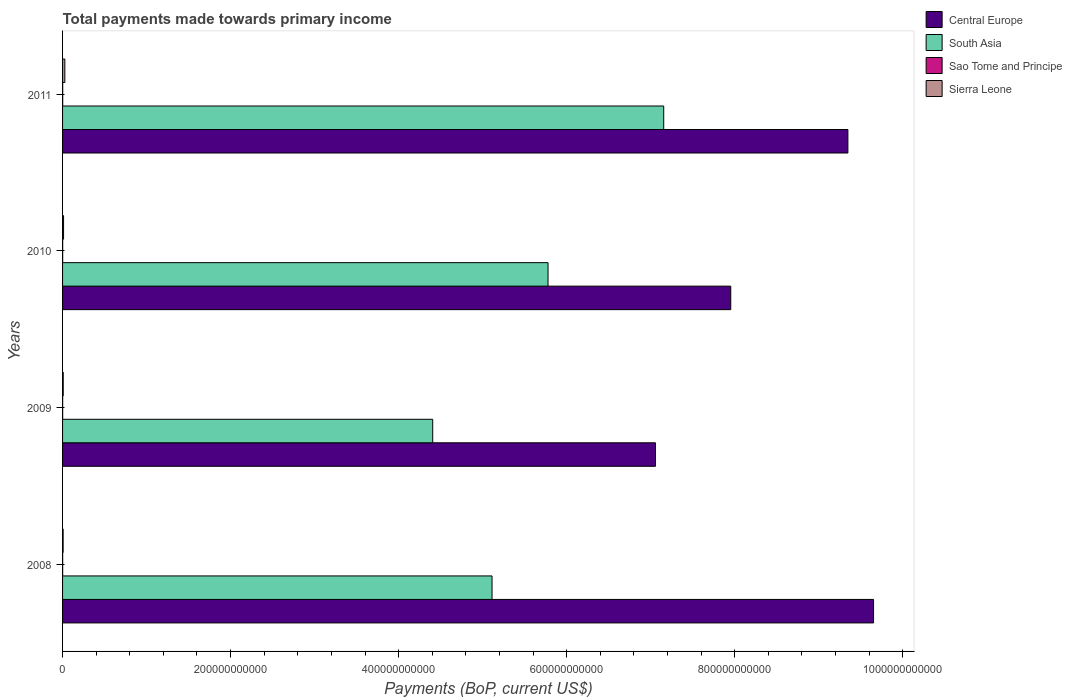How many different coloured bars are there?
Your answer should be very brief. 4. How many groups of bars are there?
Provide a short and direct response. 4. Are the number of bars per tick equal to the number of legend labels?
Your response must be concise. Yes. Are the number of bars on each tick of the Y-axis equal?
Ensure brevity in your answer.  Yes. How many bars are there on the 1st tick from the top?
Provide a succinct answer. 4. How many bars are there on the 2nd tick from the bottom?
Provide a succinct answer. 4. In how many cases, is the number of bars for a given year not equal to the number of legend labels?
Offer a very short reply. 0. What is the total payments made towards primary income in South Asia in 2009?
Your answer should be compact. 4.41e+11. Across all years, what is the maximum total payments made towards primary income in Sierra Leone?
Provide a short and direct response. 2.71e+09. Across all years, what is the minimum total payments made towards primary income in Sao Tome and Principe?
Make the answer very short. 1.05e+08. In which year was the total payments made towards primary income in Sierra Leone maximum?
Give a very brief answer. 2011. In which year was the total payments made towards primary income in Sierra Leone minimum?
Ensure brevity in your answer.  2008. What is the total total payments made towards primary income in Central Europe in the graph?
Your response must be concise. 3.40e+12. What is the difference between the total payments made towards primary income in Sierra Leone in 2009 and that in 2010?
Provide a succinct answer. -3.95e+08. What is the difference between the total payments made towards primary income in Central Europe in 2010 and the total payments made towards primary income in South Asia in 2011?
Your answer should be very brief. 7.98e+1. What is the average total payments made towards primary income in Sierra Leone per year?
Make the answer very short. 1.35e+09. In the year 2009, what is the difference between the total payments made towards primary income in Central Europe and total payments made towards primary income in South Asia?
Offer a very short reply. 2.65e+11. What is the ratio of the total payments made towards primary income in Sierra Leone in 2010 to that in 2011?
Provide a short and direct response. 0.44. Is the total payments made towards primary income in Sao Tome and Principe in 2008 less than that in 2010?
Your answer should be compact. Yes. Is the difference between the total payments made towards primary income in Central Europe in 2010 and 2011 greater than the difference between the total payments made towards primary income in South Asia in 2010 and 2011?
Make the answer very short. No. What is the difference between the highest and the second highest total payments made towards primary income in Sierra Leone?
Provide a succinct answer. 1.52e+09. What is the difference between the highest and the lowest total payments made towards primary income in South Asia?
Give a very brief answer. 2.75e+11. In how many years, is the total payments made towards primary income in Sierra Leone greater than the average total payments made towards primary income in Sierra Leone taken over all years?
Keep it short and to the point. 1. Is it the case that in every year, the sum of the total payments made towards primary income in Sierra Leone and total payments made towards primary income in South Asia is greater than the sum of total payments made towards primary income in Central Europe and total payments made towards primary income in Sao Tome and Principe?
Make the answer very short. No. What does the 2nd bar from the top in 2011 represents?
Make the answer very short. Sao Tome and Principe. What does the 1st bar from the bottom in 2011 represents?
Keep it short and to the point. Central Europe. Is it the case that in every year, the sum of the total payments made towards primary income in South Asia and total payments made towards primary income in Sierra Leone is greater than the total payments made towards primary income in Sao Tome and Principe?
Provide a short and direct response. Yes. What is the difference between two consecutive major ticks on the X-axis?
Your answer should be compact. 2.00e+11. Are the values on the major ticks of X-axis written in scientific E-notation?
Make the answer very short. No. Does the graph contain grids?
Keep it short and to the point. No. What is the title of the graph?
Offer a very short reply. Total payments made towards primary income. What is the label or title of the X-axis?
Offer a terse response. Payments (BoP, current US$). What is the label or title of the Y-axis?
Your answer should be compact. Years. What is the Payments (BoP, current US$) of Central Europe in 2008?
Provide a succinct answer. 9.65e+11. What is the Payments (BoP, current US$) in South Asia in 2008?
Provide a succinct answer. 5.11e+11. What is the Payments (BoP, current US$) in Sao Tome and Principe in 2008?
Provide a short and direct response. 1.16e+08. What is the Payments (BoP, current US$) in Sierra Leone in 2008?
Make the answer very short. 6.85e+08. What is the Payments (BoP, current US$) in Central Europe in 2009?
Ensure brevity in your answer.  7.06e+11. What is the Payments (BoP, current US$) of South Asia in 2009?
Provide a short and direct response. 4.41e+11. What is the Payments (BoP, current US$) of Sao Tome and Principe in 2009?
Make the answer very short. 1.05e+08. What is the Payments (BoP, current US$) in Sierra Leone in 2009?
Offer a very short reply. 7.97e+08. What is the Payments (BoP, current US$) of Central Europe in 2010?
Your answer should be very brief. 7.95e+11. What is the Payments (BoP, current US$) of South Asia in 2010?
Your answer should be very brief. 5.78e+11. What is the Payments (BoP, current US$) in Sao Tome and Principe in 2010?
Keep it short and to the point. 1.23e+08. What is the Payments (BoP, current US$) in Sierra Leone in 2010?
Your answer should be very brief. 1.19e+09. What is the Payments (BoP, current US$) of Central Europe in 2011?
Offer a very short reply. 9.35e+11. What is the Payments (BoP, current US$) of South Asia in 2011?
Your response must be concise. 7.16e+11. What is the Payments (BoP, current US$) of Sao Tome and Principe in 2011?
Provide a short and direct response. 1.49e+08. What is the Payments (BoP, current US$) of Sierra Leone in 2011?
Your answer should be compact. 2.71e+09. Across all years, what is the maximum Payments (BoP, current US$) of Central Europe?
Provide a succinct answer. 9.65e+11. Across all years, what is the maximum Payments (BoP, current US$) in South Asia?
Ensure brevity in your answer.  7.16e+11. Across all years, what is the maximum Payments (BoP, current US$) in Sao Tome and Principe?
Make the answer very short. 1.49e+08. Across all years, what is the maximum Payments (BoP, current US$) in Sierra Leone?
Provide a short and direct response. 2.71e+09. Across all years, what is the minimum Payments (BoP, current US$) of Central Europe?
Offer a very short reply. 7.06e+11. Across all years, what is the minimum Payments (BoP, current US$) of South Asia?
Provide a short and direct response. 4.41e+11. Across all years, what is the minimum Payments (BoP, current US$) in Sao Tome and Principe?
Provide a short and direct response. 1.05e+08. Across all years, what is the minimum Payments (BoP, current US$) of Sierra Leone?
Give a very brief answer. 6.85e+08. What is the total Payments (BoP, current US$) of Central Europe in the graph?
Give a very brief answer. 3.40e+12. What is the total Payments (BoP, current US$) in South Asia in the graph?
Your response must be concise. 2.25e+12. What is the total Payments (BoP, current US$) in Sao Tome and Principe in the graph?
Keep it short and to the point. 4.92e+08. What is the total Payments (BoP, current US$) in Sierra Leone in the graph?
Make the answer very short. 5.38e+09. What is the difference between the Payments (BoP, current US$) of Central Europe in 2008 and that in 2009?
Your answer should be very brief. 2.60e+11. What is the difference between the Payments (BoP, current US$) in South Asia in 2008 and that in 2009?
Your response must be concise. 7.06e+1. What is the difference between the Payments (BoP, current US$) in Sao Tome and Principe in 2008 and that in 2009?
Your answer should be very brief. 1.09e+07. What is the difference between the Payments (BoP, current US$) in Sierra Leone in 2008 and that in 2009?
Provide a short and direct response. -1.12e+08. What is the difference between the Payments (BoP, current US$) of Central Europe in 2008 and that in 2010?
Provide a succinct answer. 1.70e+11. What is the difference between the Payments (BoP, current US$) in South Asia in 2008 and that in 2010?
Your answer should be very brief. -6.66e+1. What is the difference between the Payments (BoP, current US$) in Sao Tome and Principe in 2008 and that in 2010?
Your response must be concise. -7.18e+06. What is the difference between the Payments (BoP, current US$) of Sierra Leone in 2008 and that in 2010?
Provide a succinct answer. -5.07e+08. What is the difference between the Payments (BoP, current US$) of Central Europe in 2008 and that in 2011?
Your response must be concise. 3.06e+1. What is the difference between the Payments (BoP, current US$) of South Asia in 2008 and that in 2011?
Your response must be concise. -2.04e+11. What is the difference between the Payments (BoP, current US$) in Sao Tome and Principe in 2008 and that in 2011?
Offer a terse response. -3.38e+07. What is the difference between the Payments (BoP, current US$) in Sierra Leone in 2008 and that in 2011?
Your answer should be very brief. -2.03e+09. What is the difference between the Payments (BoP, current US$) in Central Europe in 2009 and that in 2010?
Your response must be concise. -8.97e+1. What is the difference between the Payments (BoP, current US$) in South Asia in 2009 and that in 2010?
Your response must be concise. -1.37e+11. What is the difference between the Payments (BoP, current US$) of Sao Tome and Principe in 2009 and that in 2010?
Your answer should be very brief. -1.81e+07. What is the difference between the Payments (BoP, current US$) in Sierra Leone in 2009 and that in 2010?
Offer a terse response. -3.95e+08. What is the difference between the Payments (BoP, current US$) of Central Europe in 2009 and that in 2011?
Keep it short and to the point. -2.29e+11. What is the difference between the Payments (BoP, current US$) of South Asia in 2009 and that in 2011?
Ensure brevity in your answer.  -2.75e+11. What is the difference between the Payments (BoP, current US$) of Sao Tome and Principe in 2009 and that in 2011?
Provide a succinct answer. -4.47e+07. What is the difference between the Payments (BoP, current US$) in Sierra Leone in 2009 and that in 2011?
Keep it short and to the point. -1.91e+09. What is the difference between the Payments (BoP, current US$) of Central Europe in 2010 and that in 2011?
Make the answer very short. -1.39e+11. What is the difference between the Payments (BoP, current US$) of South Asia in 2010 and that in 2011?
Offer a very short reply. -1.38e+11. What is the difference between the Payments (BoP, current US$) of Sao Tome and Principe in 2010 and that in 2011?
Provide a short and direct response. -2.66e+07. What is the difference between the Payments (BoP, current US$) of Sierra Leone in 2010 and that in 2011?
Your response must be concise. -1.52e+09. What is the difference between the Payments (BoP, current US$) of Central Europe in 2008 and the Payments (BoP, current US$) of South Asia in 2009?
Provide a short and direct response. 5.25e+11. What is the difference between the Payments (BoP, current US$) of Central Europe in 2008 and the Payments (BoP, current US$) of Sao Tome and Principe in 2009?
Keep it short and to the point. 9.65e+11. What is the difference between the Payments (BoP, current US$) of Central Europe in 2008 and the Payments (BoP, current US$) of Sierra Leone in 2009?
Your response must be concise. 9.65e+11. What is the difference between the Payments (BoP, current US$) of South Asia in 2008 and the Payments (BoP, current US$) of Sao Tome and Principe in 2009?
Provide a short and direct response. 5.11e+11. What is the difference between the Payments (BoP, current US$) in South Asia in 2008 and the Payments (BoP, current US$) in Sierra Leone in 2009?
Provide a succinct answer. 5.10e+11. What is the difference between the Payments (BoP, current US$) in Sao Tome and Principe in 2008 and the Payments (BoP, current US$) in Sierra Leone in 2009?
Your response must be concise. -6.81e+08. What is the difference between the Payments (BoP, current US$) in Central Europe in 2008 and the Payments (BoP, current US$) in South Asia in 2010?
Make the answer very short. 3.88e+11. What is the difference between the Payments (BoP, current US$) of Central Europe in 2008 and the Payments (BoP, current US$) of Sao Tome and Principe in 2010?
Offer a very short reply. 9.65e+11. What is the difference between the Payments (BoP, current US$) in Central Europe in 2008 and the Payments (BoP, current US$) in Sierra Leone in 2010?
Provide a short and direct response. 9.64e+11. What is the difference between the Payments (BoP, current US$) of South Asia in 2008 and the Payments (BoP, current US$) of Sao Tome and Principe in 2010?
Provide a short and direct response. 5.11e+11. What is the difference between the Payments (BoP, current US$) of South Asia in 2008 and the Payments (BoP, current US$) of Sierra Leone in 2010?
Provide a succinct answer. 5.10e+11. What is the difference between the Payments (BoP, current US$) of Sao Tome and Principe in 2008 and the Payments (BoP, current US$) of Sierra Leone in 2010?
Your answer should be compact. -1.08e+09. What is the difference between the Payments (BoP, current US$) of Central Europe in 2008 and the Payments (BoP, current US$) of South Asia in 2011?
Give a very brief answer. 2.50e+11. What is the difference between the Payments (BoP, current US$) of Central Europe in 2008 and the Payments (BoP, current US$) of Sao Tome and Principe in 2011?
Your response must be concise. 9.65e+11. What is the difference between the Payments (BoP, current US$) of Central Europe in 2008 and the Payments (BoP, current US$) of Sierra Leone in 2011?
Provide a succinct answer. 9.63e+11. What is the difference between the Payments (BoP, current US$) of South Asia in 2008 and the Payments (BoP, current US$) of Sao Tome and Principe in 2011?
Make the answer very short. 5.11e+11. What is the difference between the Payments (BoP, current US$) of South Asia in 2008 and the Payments (BoP, current US$) of Sierra Leone in 2011?
Make the answer very short. 5.08e+11. What is the difference between the Payments (BoP, current US$) of Sao Tome and Principe in 2008 and the Payments (BoP, current US$) of Sierra Leone in 2011?
Provide a succinct answer. -2.60e+09. What is the difference between the Payments (BoP, current US$) in Central Europe in 2009 and the Payments (BoP, current US$) in South Asia in 2010?
Your response must be concise. 1.28e+11. What is the difference between the Payments (BoP, current US$) in Central Europe in 2009 and the Payments (BoP, current US$) in Sao Tome and Principe in 2010?
Ensure brevity in your answer.  7.06e+11. What is the difference between the Payments (BoP, current US$) in Central Europe in 2009 and the Payments (BoP, current US$) in Sierra Leone in 2010?
Your answer should be very brief. 7.05e+11. What is the difference between the Payments (BoP, current US$) in South Asia in 2009 and the Payments (BoP, current US$) in Sao Tome and Principe in 2010?
Give a very brief answer. 4.40e+11. What is the difference between the Payments (BoP, current US$) of South Asia in 2009 and the Payments (BoP, current US$) of Sierra Leone in 2010?
Make the answer very short. 4.39e+11. What is the difference between the Payments (BoP, current US$) in Sao Tome and Principe in 2009 and the Payments (BoP, current US$) in Sierra Leone in 2010?
Your answer should be compact. -1.09e+09. What is the difference between the Payments (BoP, current US$) of Central Europe in 2009 and the Payments (BoP, current US$) of South Asia in 2011?
Give a very brief answer. -9.86e+09. What is the difference between the Payments (BoP, current US$) in Central Europe in 2009 and the Payments (BoP, current US$) in Sao Tome and Principe in 2011?
Your response must be concise. 7.06e+11. What is the difference between the Payments (BoP, current US$) of Central Europe in 2009 and the Payments (BoP, current US$) of Sierra Leone in 2011?
Your response must be concise. 7.03e+11. What is the difference between the Payments (BoP, current US$) of South Asia in 2009 and the Payments (BoP, current US$) of Sao Tome and Principe in 2011?
Ensure brevity in your answer.  4.40e+11. What is the difference between the Payments (BoP, current US$) in South Asia in 2009 and the Payments (BoP, current US$) in Sierra Leone in 2011?
Your response must be concise. 4.38e+11. What is the difference between the Payments (BoP, current US$) in Sao Tome and Principe in 2009 and the Payments (BoP, current US$) in Sierra Leone in 2011?
Your response must be concise. -2.61e+09. What is the difference between the Payments (BoP, current US$) in Central Europe in 2010 and the Payments (BoP, current US$) in South Asia in 2011?
Offer a very short reply. 7.98e+1. What is the difference between the Payments (BoP, current US$) in Central Europe in 2010 and the Payments (BoP, current US$) in Sao Tome and Principe in 2011?
Your answer should be very brief. 7.95e+11. What is the difference between the Payments (BoP, current US$) in Central Europe in 2010 and the Payments (BoP, current US$) in Sierra Leone in 2011?
Keep it short and to the point. 7.93e+11. What is the difference between the Payments (BoP, current US$) in South Asia in 2010 and the Payments (BoP, current US$) in Sao Tome and Principe in 2011?
Your answer should be very brief. 5.78e+11. What is the difference between the Payments (BoP, current US$) in South Asia in 2010 and the Payments (BoP, current US$) in Sierra Leone in 2011?
Give a very brief answer. 5.75e+11. What is the difference between the Payments (BoP, current US$) in Sao Tome and Principe in 2010 and the Payments (BoP, current US$) in Sierra Leone in 2011?
Provide a succinct answer. -2.59e+09. What is the average Payments (BoP, current US$) of Central Europe per year?
Give a very brief answer. 8.50e+11. What is the average Payments (BoP, current US$) in South Asia per year?
Offer a very short reply. 5.61e+11. What is the average Payments (BoP, current US$) of Sao Tome and Principe per year?
Make the answer very short. 1.23e+08. What is the average Payments (BoP, current US$) of Sierra Leone per year?
Give a very brief answer. 1.35e+09. In the year 2008, what is the difference between the Payments (BoP, current US$) in Central Europe and Payments (BoP, current US$) in South Asia?
Ensure brevity in your answer.  4.54e+11. In the year 2008, what is the difference between the Payments (BoP, current US$) of Central Europe and Payments (BoP, current US$) of Sao Tome and Principe?
Make the answer very short. 9.65e+11. In the year 2008, what is the difference between the Payments (BoP, current US$) of Central Europe and Payments (BoP, current US$) of Sierra Leone?
Provide a short and direct response. 9.65e+11. In the year 2008, what is the difference between the Payments (BoP, current US$) in South Asia and Payments (BoP, current US$) in Sao Tome and Principe?
Offer a terse response. 5.11e+11. In the year 2008, what is the difference between the Payments (BoP, current US$) of South Asia and Payments (BoP, current US$) of Sierra Leone?
Give a very brief answer. 5.11e+11. In the year 2008, what is the difference between the Payments (BoP, current US$) in Sao Tome and Principe and Payments (BoP, current US$) in Sierra Leone?
Your response must be concise. -5.69e+08. In the year 2009, what is the difference between the Payments (BoP, current US$) in Central Europe and Payments (BoP, current US$) in South Asia?
Offer a terse response. 2.65e+11. In the year 2009, what is the difference between the Payments (BoP, current US$) in Central Europe and Payments (BoP, current US$) in Sao Tome and Principe?
Your response must be concise. 7.06e+11. In the year 2009, what is the difference between the Payments (BoP, current US$) in Central Europe and Payments (BoP, current US$) in Sierra Leone?
Offer a terse response. 7.05e+11. In the year 2009, what is the difference between the Payments (BoP, current US$) of South Asia and Payments (BoP, current US$) of Sao Tome and Principe?
Make the answer very short. 4.41e+11. In the year 2009, what is the difference between the Payments (BoP, current US$) of South Asia and Payments (BoP, current US$) of Sierra Leone?
Keep it short and to the point. 4.40e+11. In the year 2009, what is the difference between the Payments (BoP, current US$) of Sao Tome and Principe and Payments (BoP, current US$) of Sierra Leone?
Provide a short and direct response. -6.92e+08. In the year 2010, what is the difference between the Payments (BoP, current US$) in Central Europe and Payments (BoP, current US$) in South Asia?
Make the answer very short. 2.18e+11. In the year 2010, what is the difference between the Payments (BoP, current US$) in Central Europe and Payments (BoP, current US$) in Sao Tome and Principe?
Make the answer very short. 7.95e+11. In the year 2010, what is the difference between the Payments (BoP, current US$) in Central Europe and Payments (BoP, current US$) in Sierra Leone?
Give a very brief answer. 7.94e+11. In the year 2010, what is the difference between the Payments (BoP, current US$) of South Asia and Payments (BoP, current US$) of Sao Tome and Principe?
Keep it short and to the point. 5.78e+11. In the year 2010, what is the difference between the Payments (BoP, current US$) of South Asia and Payments (BoP, current US$) of Sierra Leone?
Provide a succinct answer. 5.77e+11. In the year 2010, what is the difference between the Payments (BoP, current US$) of Sao Tome and Principe and Payments (BoP, current US$) of Sierra Leone?
Your answer should be compact. -1.07e+09. In the year 2011, what is the difference between the Payments (BoP, current US$) of Central Europe and Payments (BoP, current US$) of South Asia?
Your response must be concise. 2.19e+11. In the year 2011, what is the difference between the Payments (BoP, current US$) in Central Europe and Payments (BoP, current US$) in Sao Tome and Principe?
Keep it short and to the point. 9.35e+11. In the year 2011, what is the difference between the Payments (BoP, current US$) of Central Europe and Payments (BoP, current US$) of Sierra Leone?
Ensure brevity in your answer.  9.32e+11. In the year 2011, what is the difference between the Payments (BoP, current US$) in South Asia and Payments (BoP, current US$) in Sao Tome and Principe?
Provide a short and direct response. 7.15e+11. In the year 2011, what is the difference between the Payments (BoP, current US$) of South Asia and Payments (BoP, current US$) of Sierra Leone?
Your answer should be compact. 7.13e+11. In the year 2011, what is the difference between the Payments (BoP, current US$) of Sao Tome and Principe and Payments (BoP, current US$) of Sierra Leone?
Offer a terse response. -2.56e+09. What is the ratio of the Payments (BoP, current US$) of Central Europe in 2008 to that in 2009?
Provide a succinct answer. 1.37. What is the ratio of the Payments (BoP, current US$) of South Asia in 2008 to that in 2009?
Provide a succinct answer. 1.16. What is the ratio of the Payments (BoP, current US$) in Sao Tome and Principe in 2008 to that in 2009?
Offer a terse response. 1.1. What is the ratio of the Payments (BoP, current US$) in Sierra Leone in 2008 to that in 2009?
Make the answer very short. 0.86. What is the ratio of the Payments (BoP, current US$) in Central Europe in 2008 to that in 2010?
Provide a succinct answer. 1.21. What is the ratio of the Payments (BoP, current US$) in South Asia in 2008 to that in 2010?
Your answer should be compact. 0.88. What is the ratio of the Payments (BoP, current US$) of Sao Tome and Principe in 2008 to that in 2010?
Your answer should be compact. 0.94. What is the ratio of the Payments (BoP, current US$) of Sierra Leone in 2008 to that in 2010?
Provide a succinct answer. 0.57. What is the ratio of the Payments (BoP, current US$) in Central Europe in 2008 to that in 2011?
Your answer should be very brief. 1.03. What is the ratio of the Payments (BoP, current US$) in South Asia in 2008 to that in 2011?
Ensure brevity in your answer.  0.71. What is the ratio of the Payments (BoP, current US$) in Sao Tome and Principe in 2008 to that in 2011?
Your answer should be compact. 0.77. What is the ratio of the Payments (BoP, current US$) in Sierra Leone in 2008 to that in 2011?
Keep it short and to the point. 0.25. What is the ratio of the Payments (BoP, current US$) of Central Europe in 2009 to that in 2010?
Provide a succinct answer. 0.89. What is the ratio of the Payments (BoP, current US$) of South Asia in 2009 to that in 2010?
Offer a very short reply. 0.76. What is the ratio of the Payments (BoP, current US$) of Sao Tome and Principe in 2009 to that in 2010?
Provide a short and direct response. 0.85. What is the ratio of the Payments (BoP, current US$) of Sierra Leone in 2009 to that in 2010?
Offer a very short reply. 0.67. What is the ratio of the Payments (BoP, current US$) in Central Europe in 2009 to that in 2011?
Keep it short and to the point. 0.75. What is the ratio of the Payments (BoP, current US$) in South Asia in 2009 to that in 2011?
Provide a short and direct response. 0.62. What is the ratio of the Payments (BoP, current US$) of Sao Tome and Principe in 2009 to that in 2011?
Give a very brief answer. 0.7. What is the ratio of the Payments (BoP, current US$) in Sierra Leone in 2009 to that in 2011?
Your response must be concise. 0.29. What is the ratio of the Payments (BoP, current US$) of Central Europe in 2010 to that in 2011?
Give a very brief answer. 0.85. What is the ratio of the Payments (BoP, current US$) in South Asia in 2010 to that in 2011?
Give a very brief answer. 0.81. What is the ratio of the Payments (BoP, current US$) in Sao Tome and Principe in 2010 to that in 2011?
Give a very brief answer. 0.82. What is the ratio of the Payments (BoP, current US$) of Sierra Leone in 2010 to that in 2011?
Give a very brief answer. 0.44. What is the difference between the highest and the second highest Payments (BoP, current US$) in Central Europe?
Keep it short and to the point. 3.06e+1. What is the difference between the highest and the second highest Payments (BoP, current US$) of South Asia?
Ensure brevity in your answer.  1.38e+11. What is the difference between the highest and the second highest Payments (BoP, current US$) in Sao Tome and Principe?
Provide a succinct answer. 2.66e+07. What is the difference between the highest and the second highest Payments (BoP, current US$) in Sierra Leone?
Your answer should be compact. 1.52e+09. What is the difference between the highest and the lowest Payments (BoP, current US$) of Central Europe?
Give a very brief answer. 2.60e+11. What is the difference between the highest and the lowest Payments (BoP, current US$) in South Asia?
Offer a terse response. 2.75e+11. What is the difference between the highest and the lowest Payments (BoP, current US$) in Sao Tome and Principe?
Offer a terse response. 4.47e+07. What is the difference between the highest and the lowest Payments (BoP, current US$) of Sierra Leone?
Give a very brief answer. 2.03e+09. 